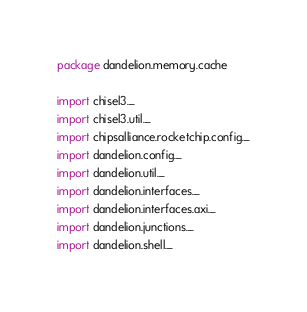<code> <loc_0><loc_0><loc_500><loc_500><_Scala_>package dandelion.memory.cache

import chisel3._
import chisel3.util._
import chipsalliance.rocketchip.config._
import dandelion.config._
import dandelion.util._
import dandelion.interfaces._
import dandelion.interfaces.axi._
import dandelion.junctions._
import dandelion.shell._

</code> 